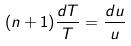Convert formula to latex. <formula><loc_0><loc_0><loc_500><loc_500>( n + 1 ) \frac { d T } { T } = \frac { d u } { u }</formula> 